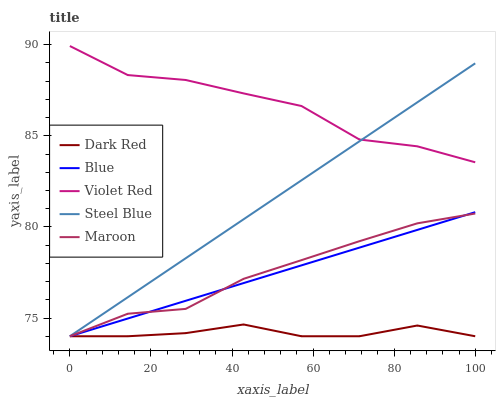Does Dark Red have the minimum area under the curve?
Answer yes or no. Yes. Does Violet Red have the maximum area under the curve?
Answer yes or no. Yes. Does Violet Red have the minimum area under the curve?
Answer yes or no. No. Does Dark Red have the maximum area under the curve?
Answer yes or no. No. Is Blue the smoothest?
Answer yes or no. Yes. Is Violet Red the roughest?
Answer yes or no. Yes. Is Dark Red the smoothest?
Answer yes or no. No. Is Dark Red the roughest?
Answer yes or no. No. Does Blue have the lowest value?
Answer yes or no. Yes. Does Violet Red have the lowest value?
Answer yes or no. No. Does Violet Red have the highest value?
Answer yes or no. Yes. Does Dark Red have the highest value?
Answer yes or no. No. Is Blue less than Violet Red?
Answer yes or no. Yes. Is Violet Red greater than Maroon?
Answer yes or no. Yes. Does Dark Red intersect Steel Blue?
Answer yes or no. Yes. Is Dark Red less than Steel Blue?
Answer yes or no. No. Is Dark Red greater than Steel Blue?
Answer yes or no. No. Does Blue intersect Violet Red?
Answer yes or no. No. 